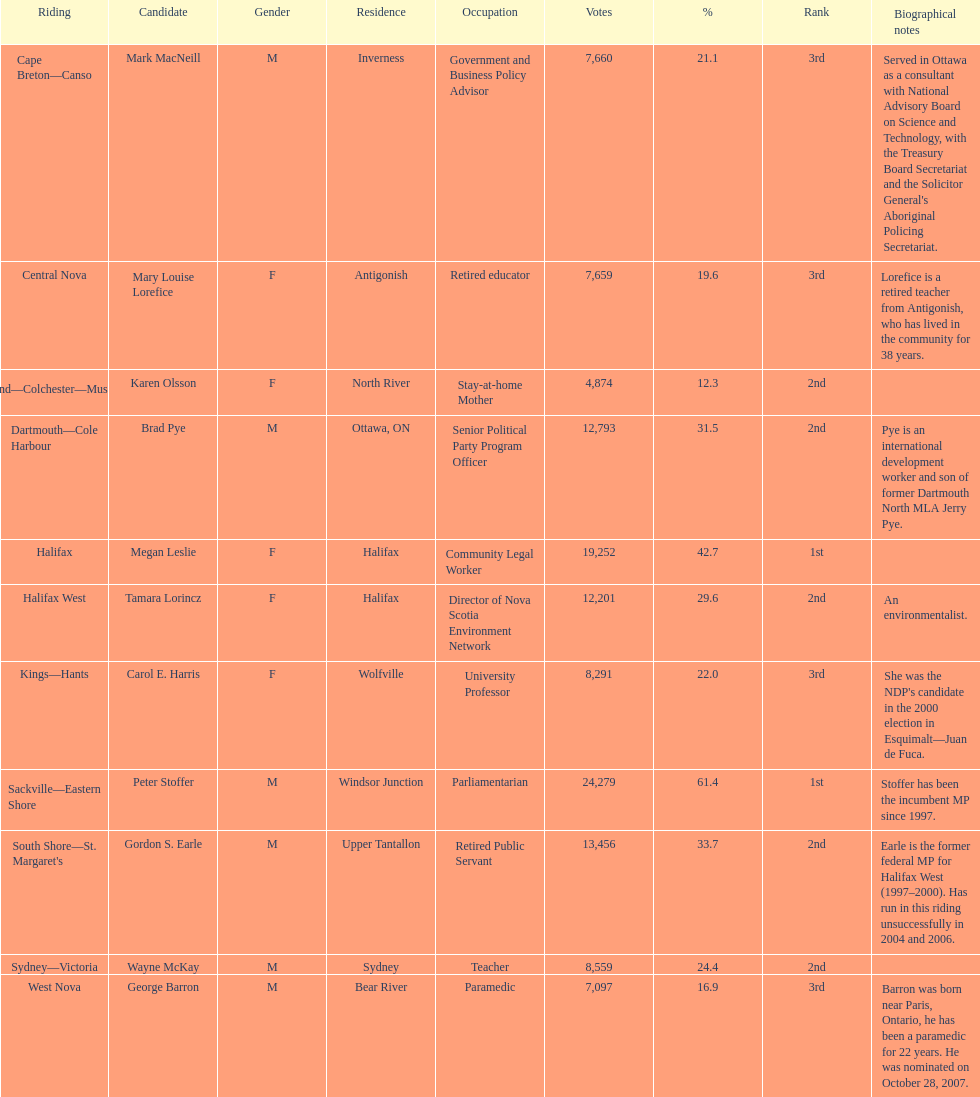What is the number of votes that megan leslie received? 19,252. 